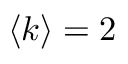<formula> <loc_0><loc_0><loc_500><loc_500>\langle k \rangle = 2</formula> 